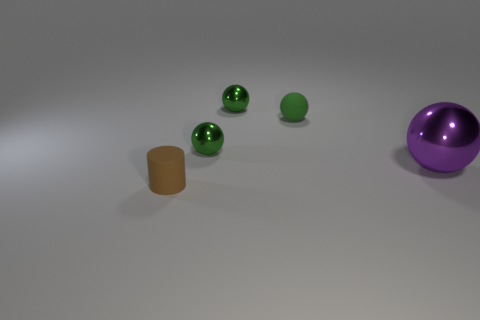How many green spheres must be subtracted to get 1 green spheres? 2 Subtract all green cubes. How many green balls are left? 3 Add 4 big blue shiny balls. How many objects exist? 9 Subtract all spheres. How many objects are left? 1 Add 4 brown matte cylinders. How many brown matte cylinders exist? 5 Subtract 1 brown cylinders. How many objects are left? 4 Subtract all purple cylinders. Subtract all small green metal spheres. How many objects are left? 3 Add 2 metal spheres. How many metal spheres are left? 5 